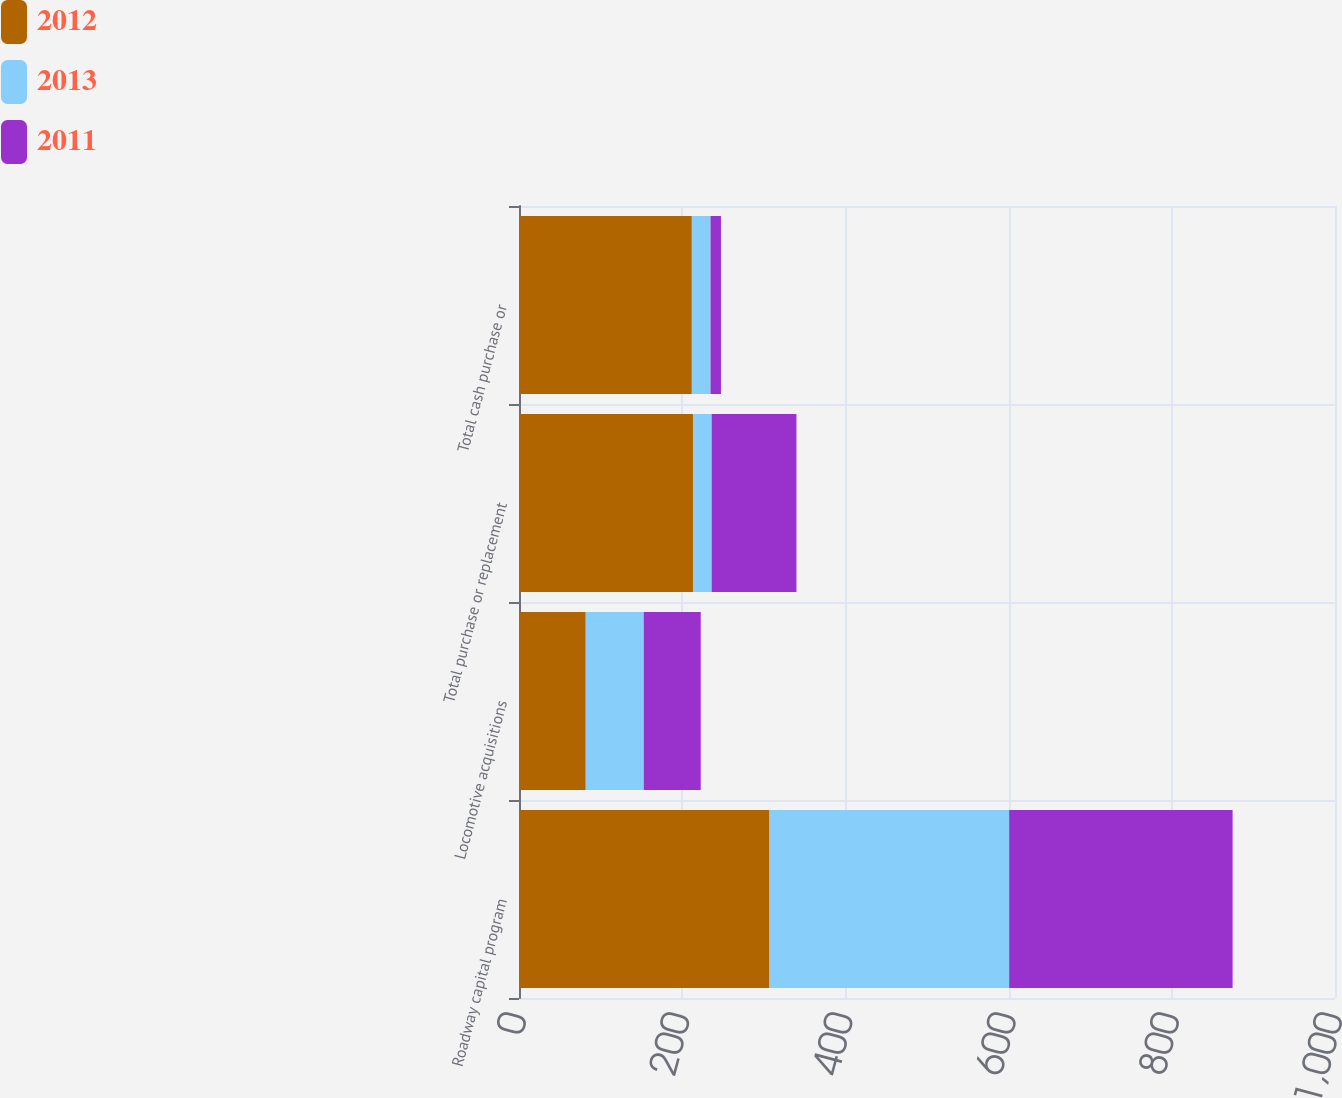Convert chart. <chart><loc_0><loc_0><loc_500><loc_500><stacked_bar_chart><ecel><fcel>Roadway capital program<fcel>Locomotive acquisitions<fcel>Total purchase or replacement<fcel>Total cash purchase or<nl><fcel>2012<fcel>307<fcel>81.8<fcel>213.2<fcel>211.8<nl><fcel>2013<fcel>293.7<fcel>71.1<fcel>22.9<fcel>22.9<nl><fcel>2011<fcel>273.8<fcel>69.8<fcel>103.9<fcel>12.8<nl></chart> 